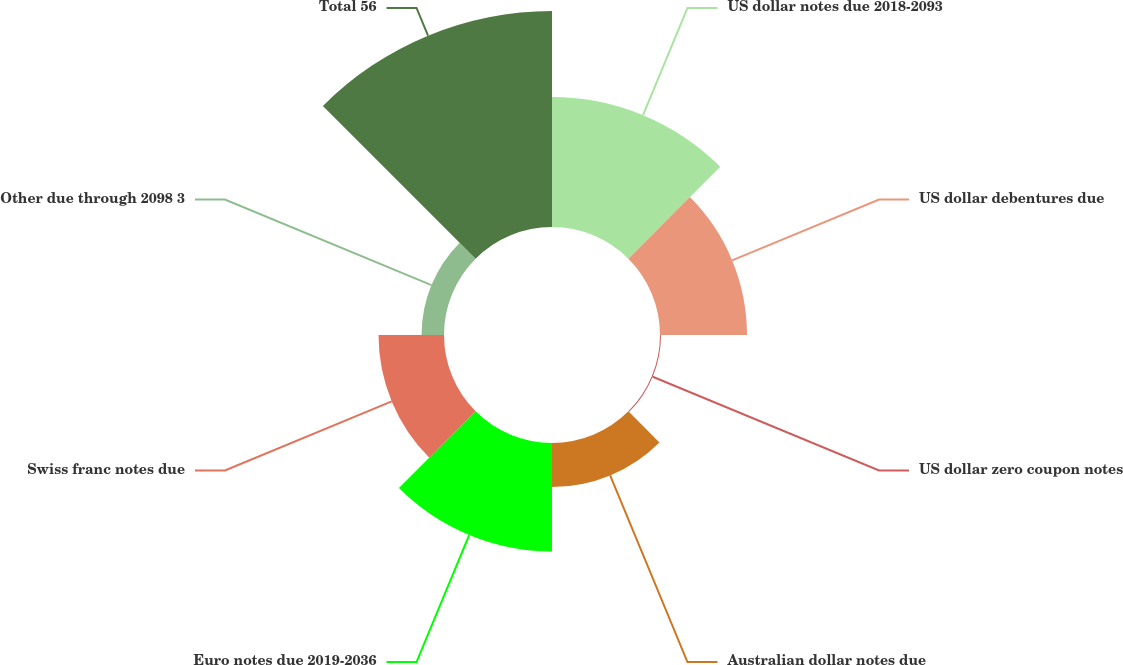<chart> <loc_0><loc_0><loc_500><loc_500><pie_chart><fcel>US dollar notes due 2018-2093<fcel>US dollar debentures due<fcel>US dollar zero coupon notes<fcel>Australian dollar notes due<fcel>Euro notes due 2019-2036<fcel>Swiss franc notes due<fcel>Other due through 2098 3<fcel>Total 56<nl><fcel>19.27%<fcel>12.9%<fcel>0.15%<fcel>6.52%<fcel>16.09%<fcel>9.71%<fcel>3.33%<fcel>32.03%<nl></chart> 